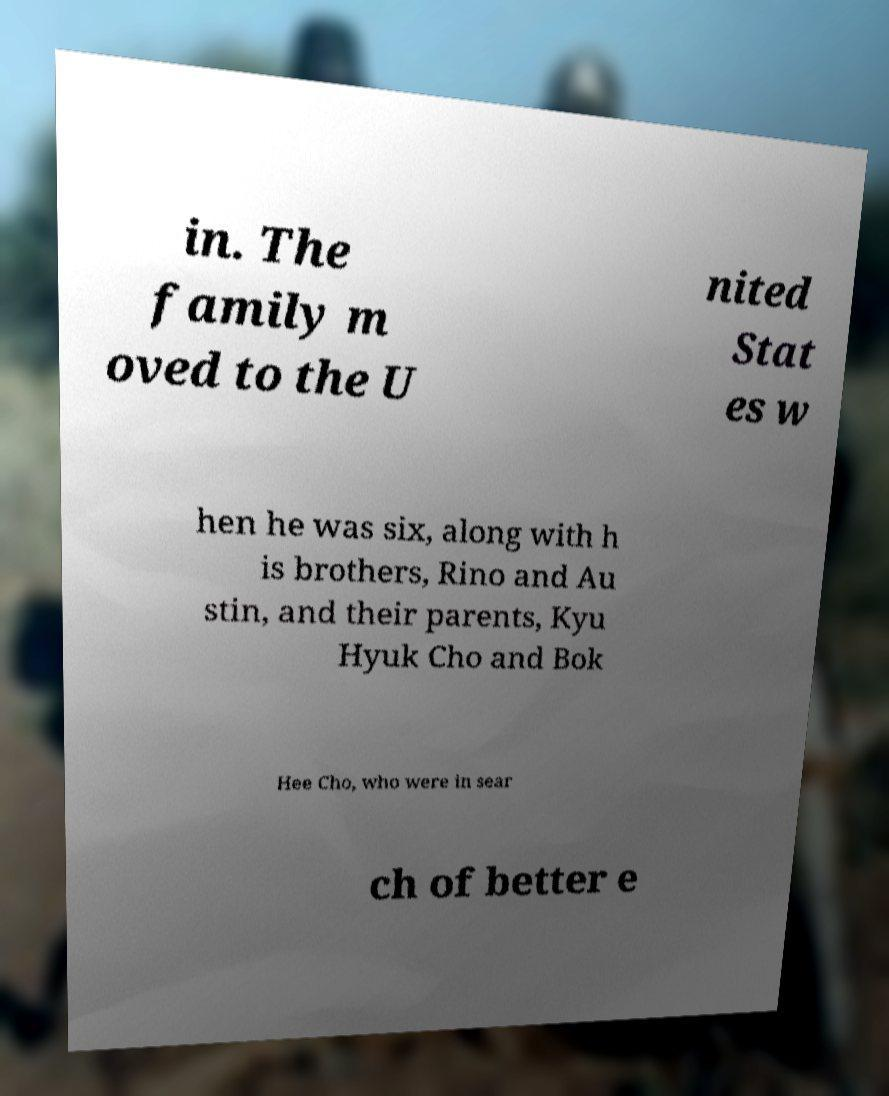Can you accurately transcribe the text from the provided image for me? in. The family m oved to the U nited Stat es w hen he was six, along with h is brothers, Rino and Au stin, and their parents, Kyu Hyuk Cho and Bok Hee Cho, who were in sear ch of better e 